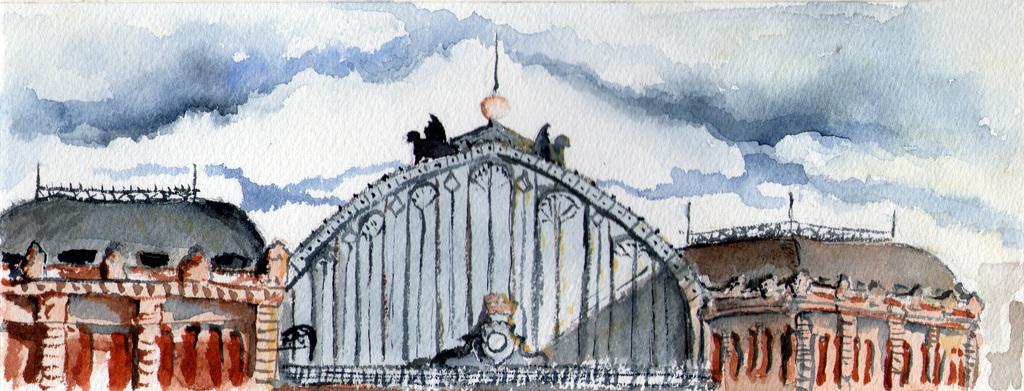What is depicted in the image? The image contains a drawing of buildings. What else is included in the drawing besides the buildings? The drawing includes the sky. Are there any specific features in the sky within the drawing? Clouds are present in the drawing. Can you tell me how many people are talking in the drawing? There are no people depicted in the drawing, so it is not possible to determine how many people might be talking. 